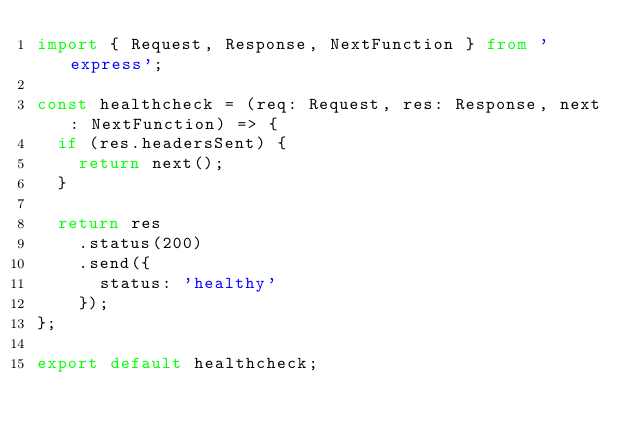<code> <loc_0><loc_0><loc_500><loc_500><_TypeScript_>import { Request, Response, NextFunction } from 'express';

const healthcheck = (req: Request, res: Response, next: NextFunction) => {
  if (res.headersSent) {
    return next();
  }

  return res
    .status(200)
    .send({
      status: 'healthy'
    });
};

export default healthcheck;
</code> 